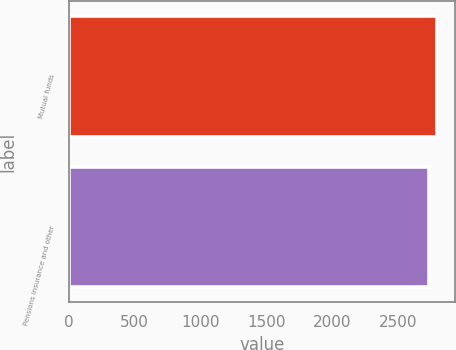Convert chart to OTSL. <chart><loc_0><loc_0><loc_500><loc_500><bar_chart><fcel>Mutual funds<fcel>Pensions insurance and other<nl><fcel>2794<fcel>2737<nl></chart> 